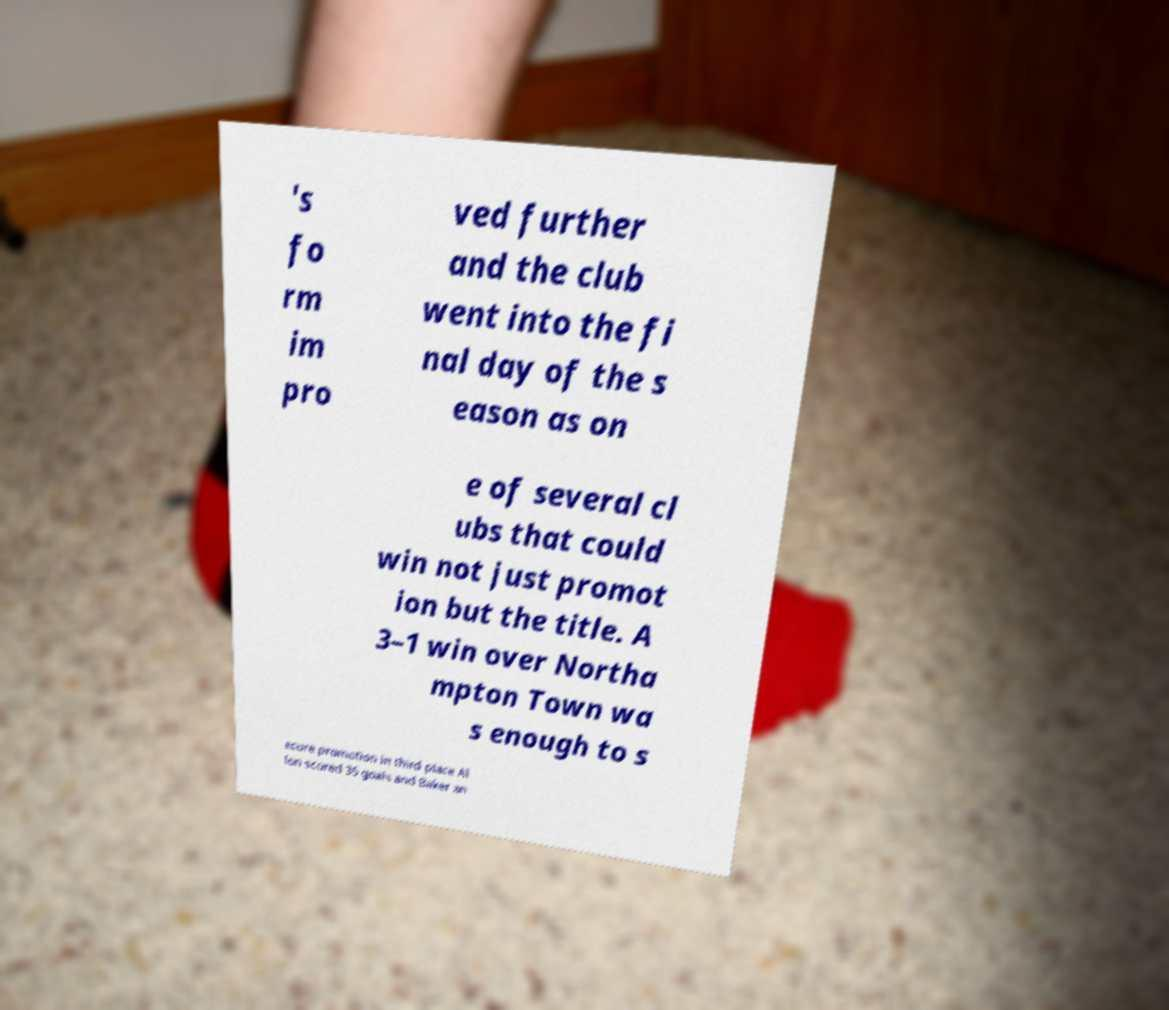Could you extract and type out the text from this image? 's fo rm im pro ved further and the club went into the fi nal day of the s eason as on e of several cl ubs that could win not just promot ion but the title. A 3–1 win over Northa mpton Town wa s enough to s ecure promotion in third place Al lon scored 35 goals and Baker an 